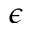Convert formula to latex. <formula><loc_0><loc_0><loc_500><loc_500>\epsilon</formula> 